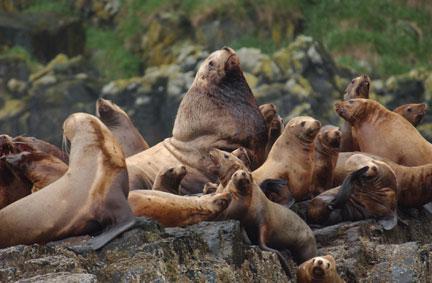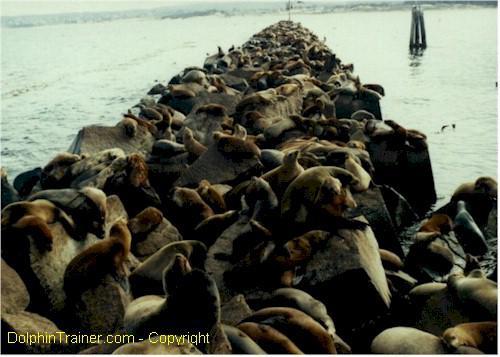The first image is the image on the left, the second image is the image on the right. Given the left and right images, does the statement "Seals are in various poses atop large rocks that extend out into the water, with water on both sides, in one image." hold true? Answer yes or no. Yes. The first image is the image on the left, the second image is the image on the right. For the images displayed, is the sentence "There are at least 5 brown seal in a group with there head head high in at least four directions." factually correct? Answer yes or no. Yes. 